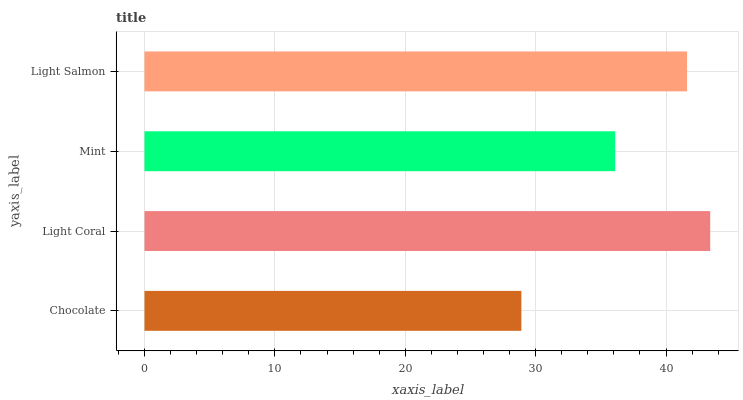Is Chocolate the minimum?
Answer yes or no. Yes. Is Light Coral the maximum?
Answer yes or no. Yes. Is Mint the minimum?
Answer yes or no. No. Is Mint the maximum?
Answer yes or no. No. Is Light Coral greater than Mint?
Answer yes or no. Yes. Is Mint less than Light Coral?
Answer yes or no. Yes. Is Mint greater than Light Coral?
Answer yes or no. No. Is Light Coral less than Mint?
Answer yes or no. No. Is Light Salmon the high median?
Answer yes or no. Yes. Is Mint the low median?
Answer yes or no. Yes. Is Chocolate the high median?
Answer yes or no. No. Is Chocolate the low median?
Answer yes or no. No. 